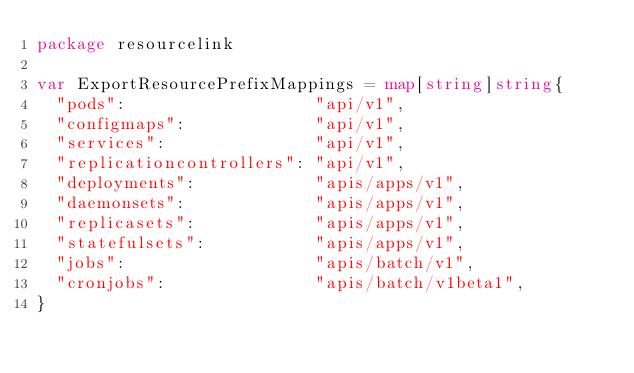<code> <loc_0><loc_0><loc_500><loc_500><_Go_>package resourcelink

var ExportResourcePrefixMappings = map[string]string{
	"pods":                   "api/v1",
	"configmaps":             "api/v1",
	"services":               "api/v1",
	"replicationcontrollers": "api/v1",
	"deployments":            "apis/apps/v1",
	"daemonsets":             "apis/apps/v1",
	"replicasets":            "apis/apps/v1",
	"statefulsets":           "apis/apps/v1",
	"jobs":                   "apis/batch/v1",
	"cronjobs":               "apis/batch/v1beta1",
}
</code> 